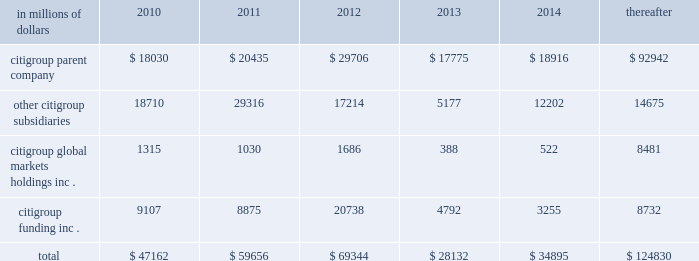Cgmhi also has substantial borrowing arrangements consisting of facilities that cgmhi has been advised are available , but where no contractual lending obligation exists .
These arrangements are reviewed on an ongoing basis to ensure flexibility in meeting cgmhi 2019s short-term requirements .
The company issues both fixed and variable rate debt in a range of currencies .
It uses derivative contracts , primarily interest rate swaps , to effectively convert a portion of its fixed rate debt to variable rate debt and variable rate debt to fixed rate debt .
The maturity structure of the derivatives generally corresponds to the maturity structure of the debt being hedged .
In addition , the company uses other derivative contracts to manage the foreign exchange impact of certain debt issuances .
At december 31 , 2009 , the company 2019s overall weighted average interest rate for long-term debt was 3.51% ( 3.51 % ) on a contractual basis and 3.91% ( 3.91 % ) including the effects of derivative contracts .
Aggregate annual maturities of long-term debt obligations ( based on final maturity dates ) including trust preferred securities are as follows: .
Long-term debt at december 31 , 2009 and december 31 , 2008 includes $ 19345 million and $ 24060 million , respectively , of junior subordinated debt .
The company formed statutory business trusts under the laws of the state of delaware .
The trusts exist for the exclusive purposes of ( i ) issuing trust securities representing undivided beneficial interests in the assets of the trust ; ( ii ) investing the gross proceeds of the trust securities in junior subordinated deferrable interest debentures ( subordinated debentures ) of its parent ; and ( iii ) engaging in only those activities necessary or incidental thereto .
Upon approval from the federal reserve , citigroup has the right to redeem these securities .
Citigroup has contractually agreed not to redeem or purchase ( i ) the 6.50% ( 6.50 % ) enhanced trust preferred securities of citigroup capital xv before september 15 , 2056 , ( ii ) the 6.45% ( 6.45 % ) enhanced trust preferred securities of citigroup capital xvi before december 31 , 2046 , ( iii ) the 6.35% ( 6.35 % ) enhanced trust preferred securities of citigroup capital xvii before march 15 , 2057 , ( iv ) the 6.829% ( 6.829 % ) fixed rate/floating rate enhanced trust preferred securities of citigroup capital xviii before june 28 , 2047 , ( v ) the 7.250% ( 7.250 % ) enhanced trust preferred securities of citigroup capital xix before august 15 , 2047 , ( vi ) the 7.875% ( 7.875 % ) enhanced trust preferred securities of citigroup capital xx before december 15 , 2067 , and ( vii ) the 8.300% ( 8.300 % ) fixed rate/floating rate enhanced trust preferred securities of citigroup capital xxi before december 21 , 2067 , unless certain conditions , described in exhibit 4.03 to citigroup 2019s current report on form 8-k filed on september 18 , 2006 , in exhibit 4.02 to citigroup 2019s current report on form 8-k filed on november 28 , 2006 , in exhibit 4.02 to citigroup 2019s current report on form 8-k filed on march 8 , 2007 , in exhibit 4.02 to citigroup 2019s current report on form 8-k filed on july 2 , 2007 , in exhibit 4.02 to citigroup 2019s current report on form 8-k filed on august 17 , 2007 , in exhibit 4.2 to citigroup 2019s current report on form 8-k filed on november 27 , 2007 , and in exhibit 4.2 to citigroup 2019s current report on form 8-k filed on december 21 , 2007 , respectively , are met .
These agreements are for the benefit of the holders of citigroup 2019s 6.00% ( 6.00 % ) junior subordinated deferrable interest debentures due 2034 .
Citigroup owns all of the voting securities of these subsidiary trusts .
These subsidiary trusts have no assets , operations , revenues or cash flows other than those related to the issuance , administration , and repayment of the subsidiary trusts and the subsidiary trusts 2019 common securities .
These subsidiary trusts 2019 obligations are fully and unconditionally guaranteed by citigroup. .
What is the total of aggregate annual maturities of long-term debt obligations for citigroup parent company in millions? 
Computations: table_sum(citigroup parent company, none)
Answer: 197804.0. 